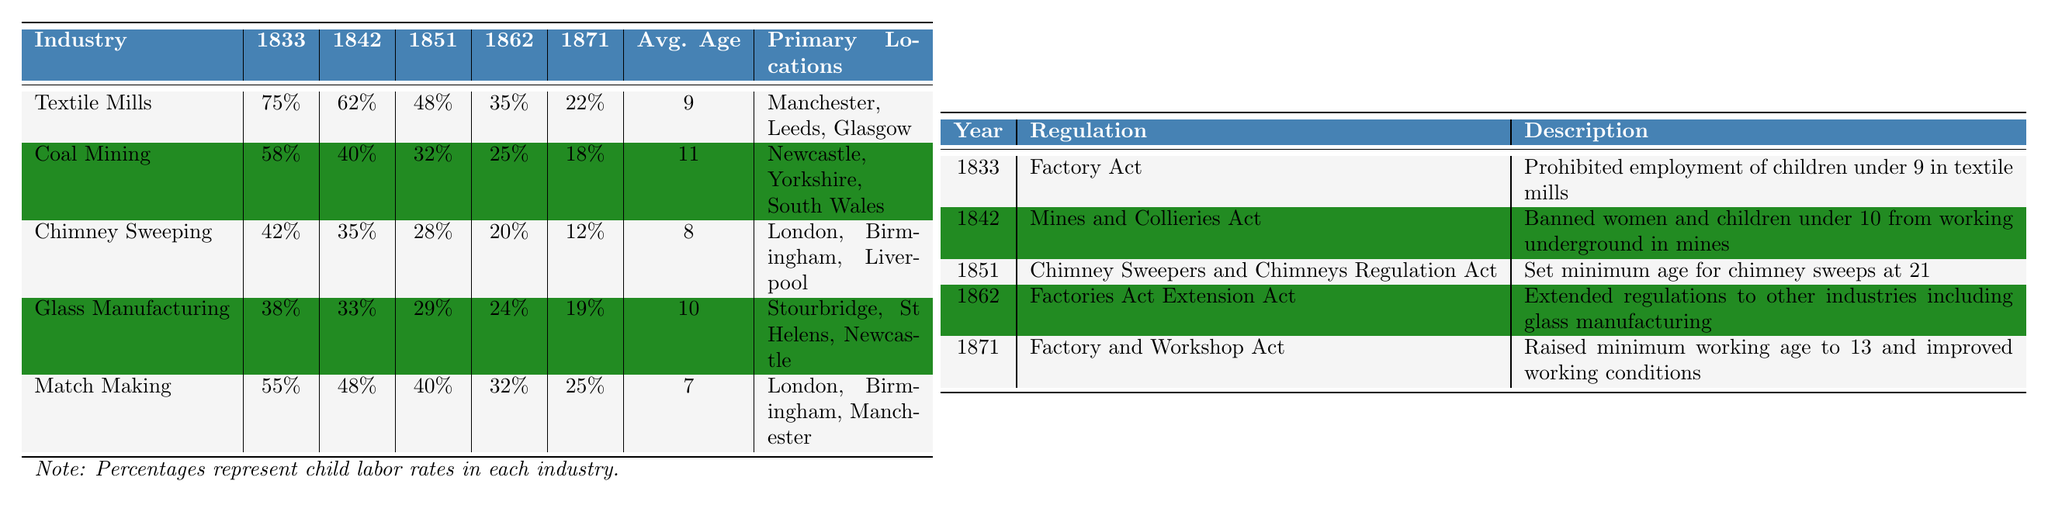What was the percentage of child labor in Textile Mills in 1833? The table shows that the percentage of child labor in Textile Mills for the year 1833 is 75%.
Answer: 75% Which industry had the lowest percentage of child labor in 1871? Looking at the data for 1871, the industry with the lowest percentage of child labor is Textile Mills, with a value of 22%.
Answer: Textile Mills What is the average age of child laborers in the Match Making industry? The average age for child laborers in the Match Making industry is given as 7 years.
Answer: 7 How much did child labor percentage decrease in Coal Mining from 1833 to 1871? In Coal Mining, the child labor percentage decreased from 58% in 1833 to 18% in 1871. The difference is 58% - 18% = 40%.
Answer: 40% Which industry saw the most significant decline in child labor percentage from 1833 to 1871? We can calculate the decline for each industry: Textile Mills (75% to 22%, 53%), Coal Mining (58% to 18%, 40%), Chimney Sweeping (42% to 12%, 30%), Glass Manufacturing (38% to 19%, 19%), and Match Making (55% to 25%, 30%). The largest decline is in Textile Mills with a 53% decrease.
Answer: Textile Mills Did the average age of child laborers increase in Coal Mining from 1833 to 1871? The average age of child laborers in Coal Mining is 11 years and did not change from 1833 to 1871, so it did not increase.
Answer: No What is the difference in the percentage of child labor between Chimney Sweeping in 1842 and Glass Manufacturing in 1851? The percentage for Chimney Sweeping in 1842 is 35%, and for Glass Manufacturing in 1851, it is 29%. The difference is 35% - 29% = 6%.
Answer: 6% Identify the year in which the Factory Act was enacted and its main provision. The Factory Act was enacted in 1833, prohibiting employment of children under 9 in textile mills.
Answer: 1833, prohibited employment of children under 9 in textile mills How did regulatory changes impact child labor trends from 1833 to 1871? Analyzing the data, we observe a general decline in the percentages of child labor across most industries from 1833 to 1871, reflecting the effectiveness of regulatory changes like the Factory Act and others.
Answer: General decline in child labor percentage Which primary location was associated with the highest child labor percentage in 1833? Textile Mills had the highest percentage of child laborers at 75%, and its primary locations include Manchester, Leeds, and Glasgow.
Answer: Manchester, Leeds, Glasgow 